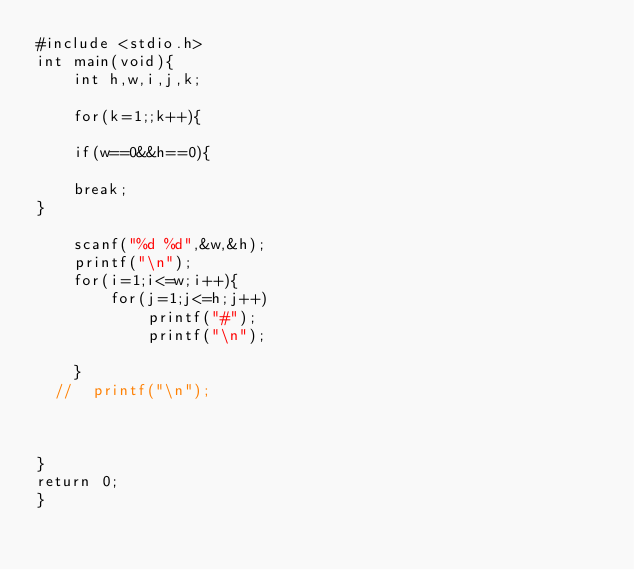<code> <loc_0><loc_0><loc_500><loc_500><_C_>#include <stdio.h>
int main(void){
    int h,w,i,j,k;

    for(k=1;;k++){

    if(w==0&&h==0){
        
    break;
}

    scanf("%d %d",&w,&h);
    printf("\n");
    for(i=1;i<=w;i++){
        for(j=1;j<=h;j++)
            printf("#");
            printf("\n");
        
    }
  //  printf("\n");
 
    
   
}
return 0;
}

</code> 